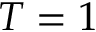<formula> <loc_0><loc_0><loc_500><loc_500>T = 1</formula> 